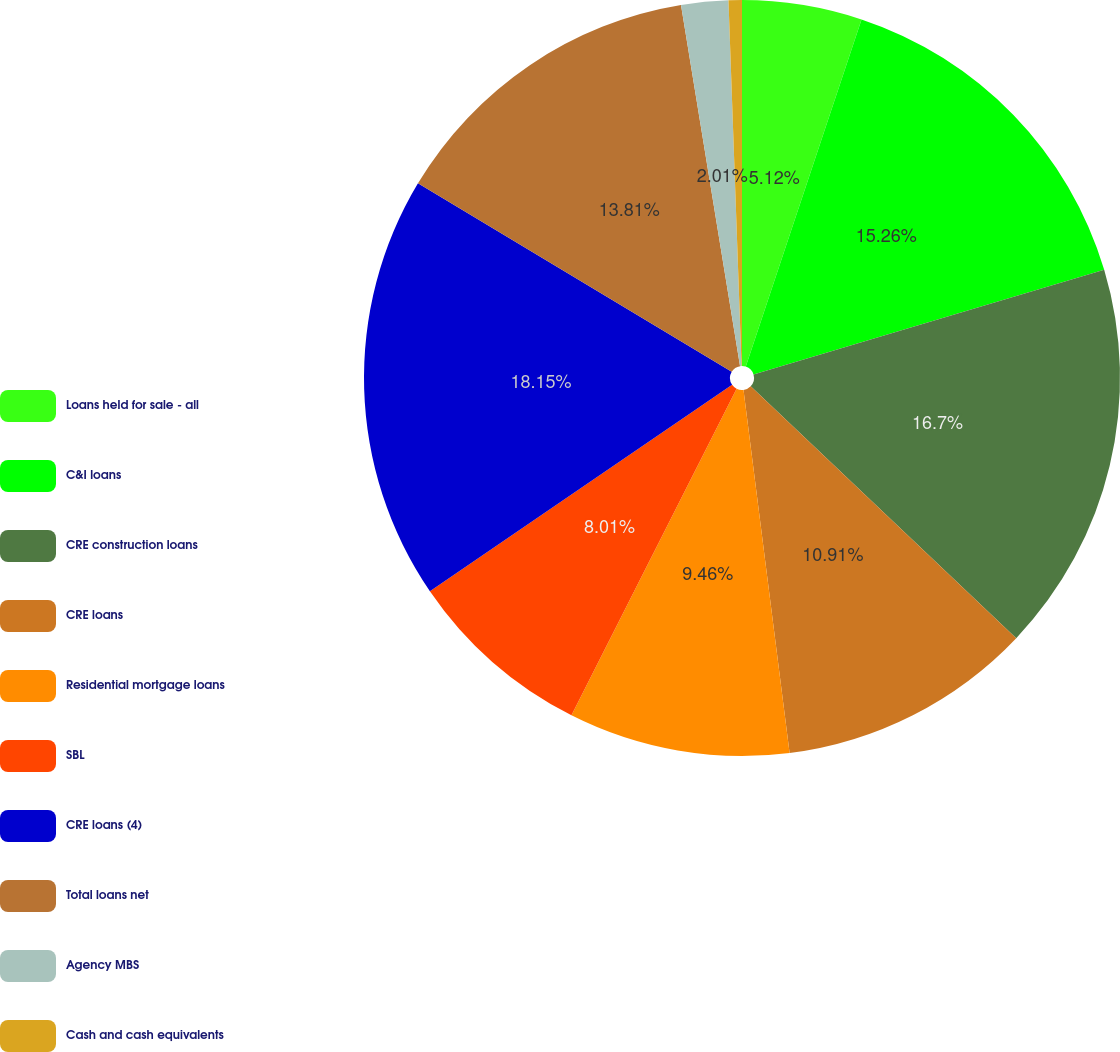<chart> <loc_0><loc_0><loc_500><loc_500><pie_chart><fcel>Loans held for sale - all<fcel>C&I loans<fcel>CRE construction loans<fcel>CRE loans<fcel>Residential mortgage loans<fcel>SBL<fcel>CRE loans (4)<fcel>Total loans net<fcel>Agency MBS<fcel>Cash and cash equivalents<nl><fcel>5.12%<fcel>15.26%<fcel>16.7%<fcel>10.91%<fcel>9.46%<fcel>8.01%<fcel>18.15%<fcel>13.81%<fcel>2.01%<fcel>0.57%<nl></chart> 